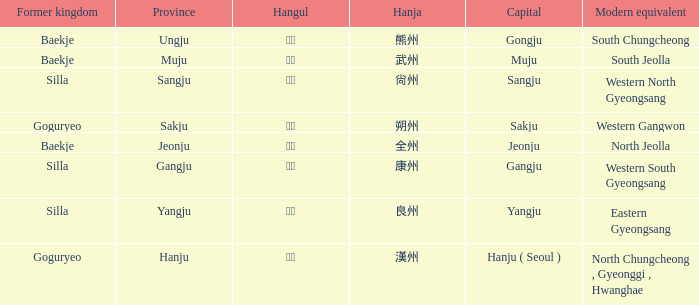What is the contemporary counterpart of the ancient kingdom "silla" with the hanja 尙州? 1.0. Give me the full table as a dictionary. {'header': ['Former kingdom', 'Province', 'Hangul', 'Hanja', 'Capital', 'Modern equivalent'], 'rows': [['Baekje', 'Ungju', '웅주', '熊州', 'Gongju', 'South Chungcheong'], ['Baekje', 'Muju', '무주', '武州', 'Muju', 'South Jeolla'], ['Silla', 'Sangju', '상주', '尙州', 'Sangju', 'Western North Gyeongsang'], ['Goguryeo', 'Sakju', '삭주', '朔州', 'Sakju', 'Western Gangwon'], ['Baekje', 'Jeonju', '전주', '全州', 'Jeonju', 'North Jeolla'], ['Silla', 'Gangju', '강주', '康州', 'Gangju', 'Western South Gyeongsang'], ['Silla', 'Yangju', '양주', '良州', 'Yangju', 'Eastern Gyeongsang'], ['Goguryeo', 'Hanju', '한주', '漢州', 'Hanju ( Seoul )', 'North Chungcheong , Gyeonggi , Hwanghae']]} 